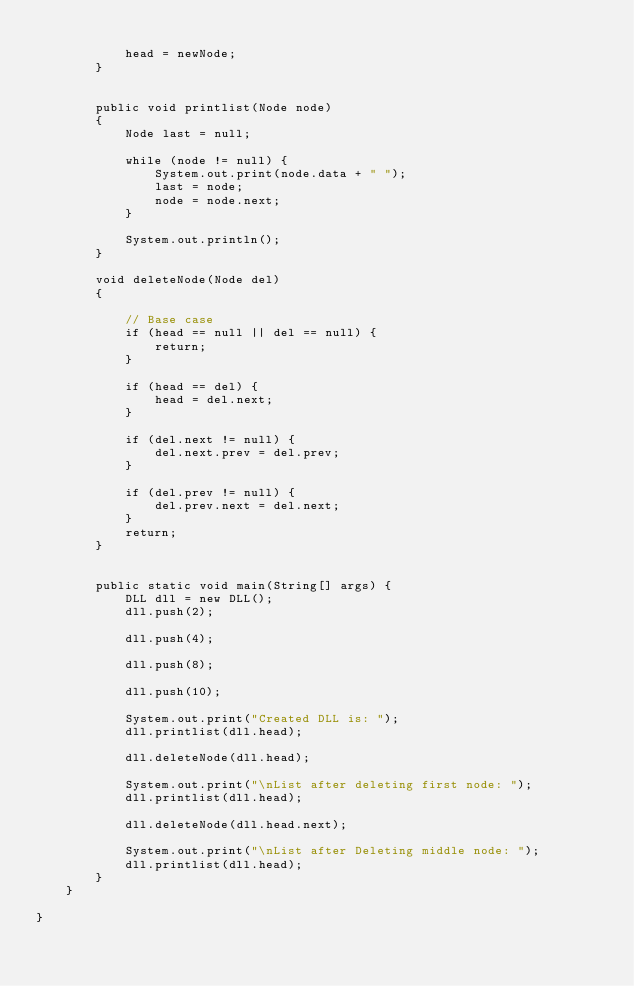<code> <loc_0><loc_0><loc_500><loc_500><_Java_>
            head = newNode;
        }


        public void printlist(Node node)
        {
            Node last = null;

            while (node != null) {
                System.out.print(node.data + " ");
                last = node;
                node = node.next;
            }

            System.out.println();
        }

        void deleteNode(Node del)
        {

            // Base case
            if (head == null || del == null) {
                return;
            }

            if (head == del) {
                head = del.next;
            }

            if (del.next != null) {
                del.next.prev = del.prev;
            }

            if (del.prev != null) {
                del.prev.next = del.next;
            }
            return;
        }


        public static void main(String[] args) {
            DLL dll = new DLL();
            dll.push(2);

            dll.push(4);

            dll.push(8);

            dll.push(10);

            System.out.print("Created DLL is: ");
            dll.printlist(dll.head);

            dll.deleteNode(dll.head);

            System.out.print("\nList after deleting first node: ");
            dll.printlist(dll.head);

            dll.deleteNode(dll.head.next);

            System.out.print("\nList after Deleting middle node: ");
            dll.printlist(dll.head);
        }
    }

}
</code> 